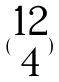<formula> <loc_0><loc_0><loc_500><loc_500>( \begin{matrix} 1 2 \\ 4 \end{matrix} )</formula> 